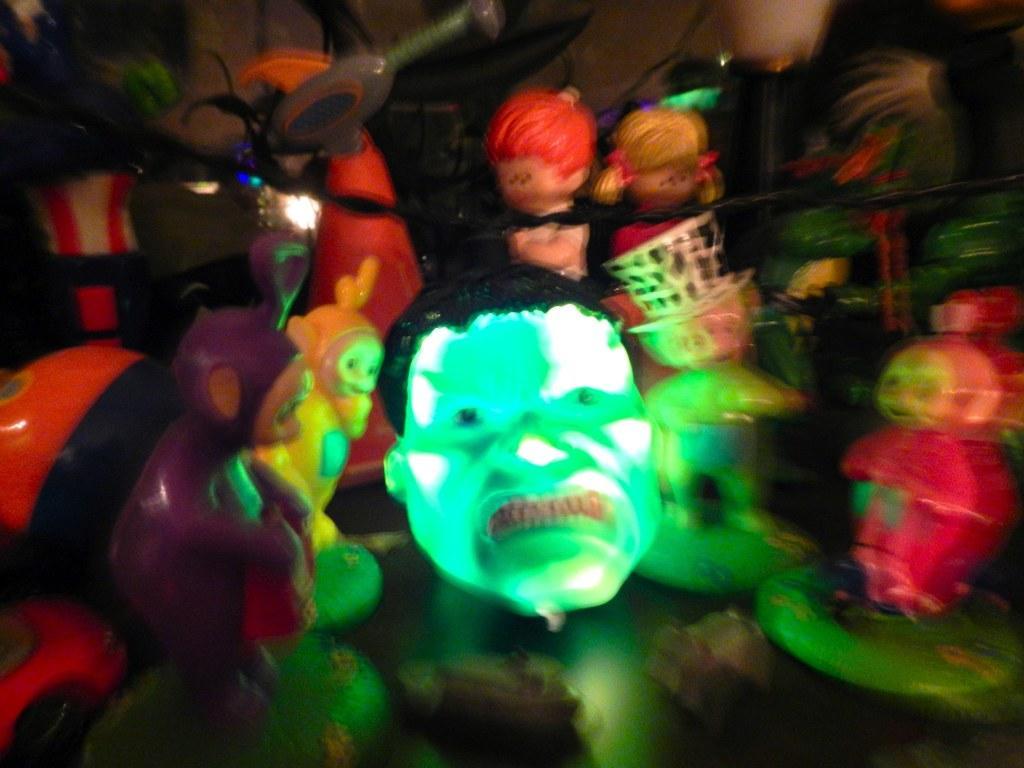In one or two sentences, can you explain what this image depicts? In the foreground of this picture, there are many toys and a man face toy in green color is in the center. 